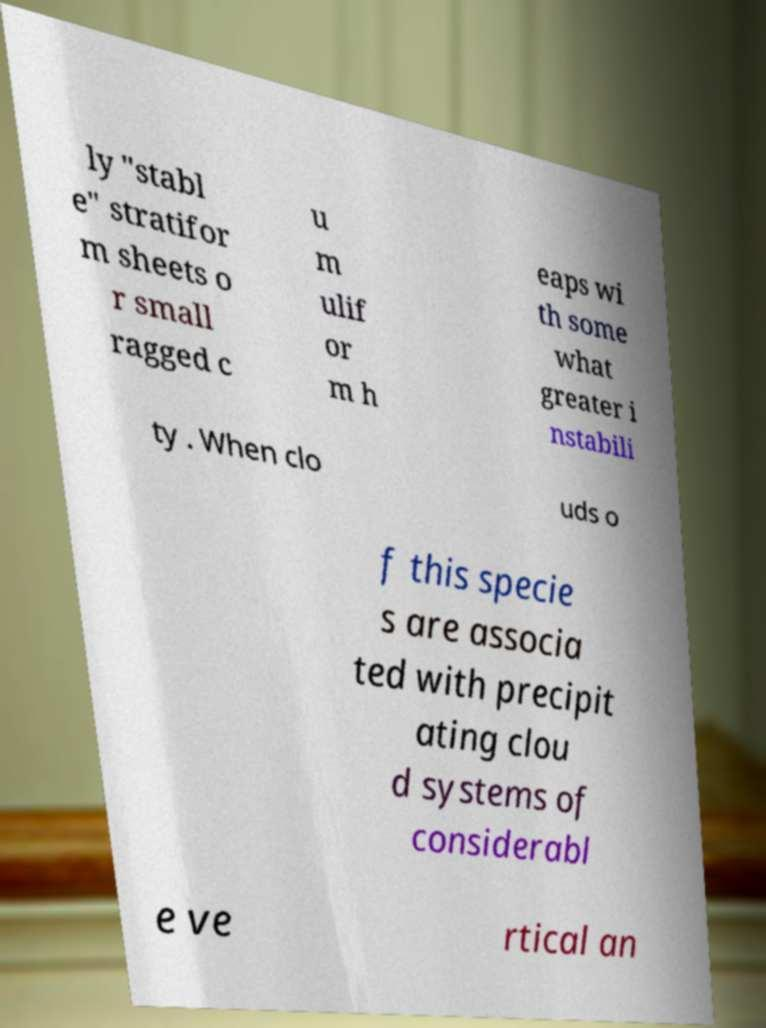Could you extract and type out the text from this image? ly "stabl e" stratifor m sheets o r small ragged c u m ulif or m h eaps wi th some what greater i nstabili ty . When clo uds o f this specie s are associa ted with precipit ating clou d systems of considerabl e ve rtical an 